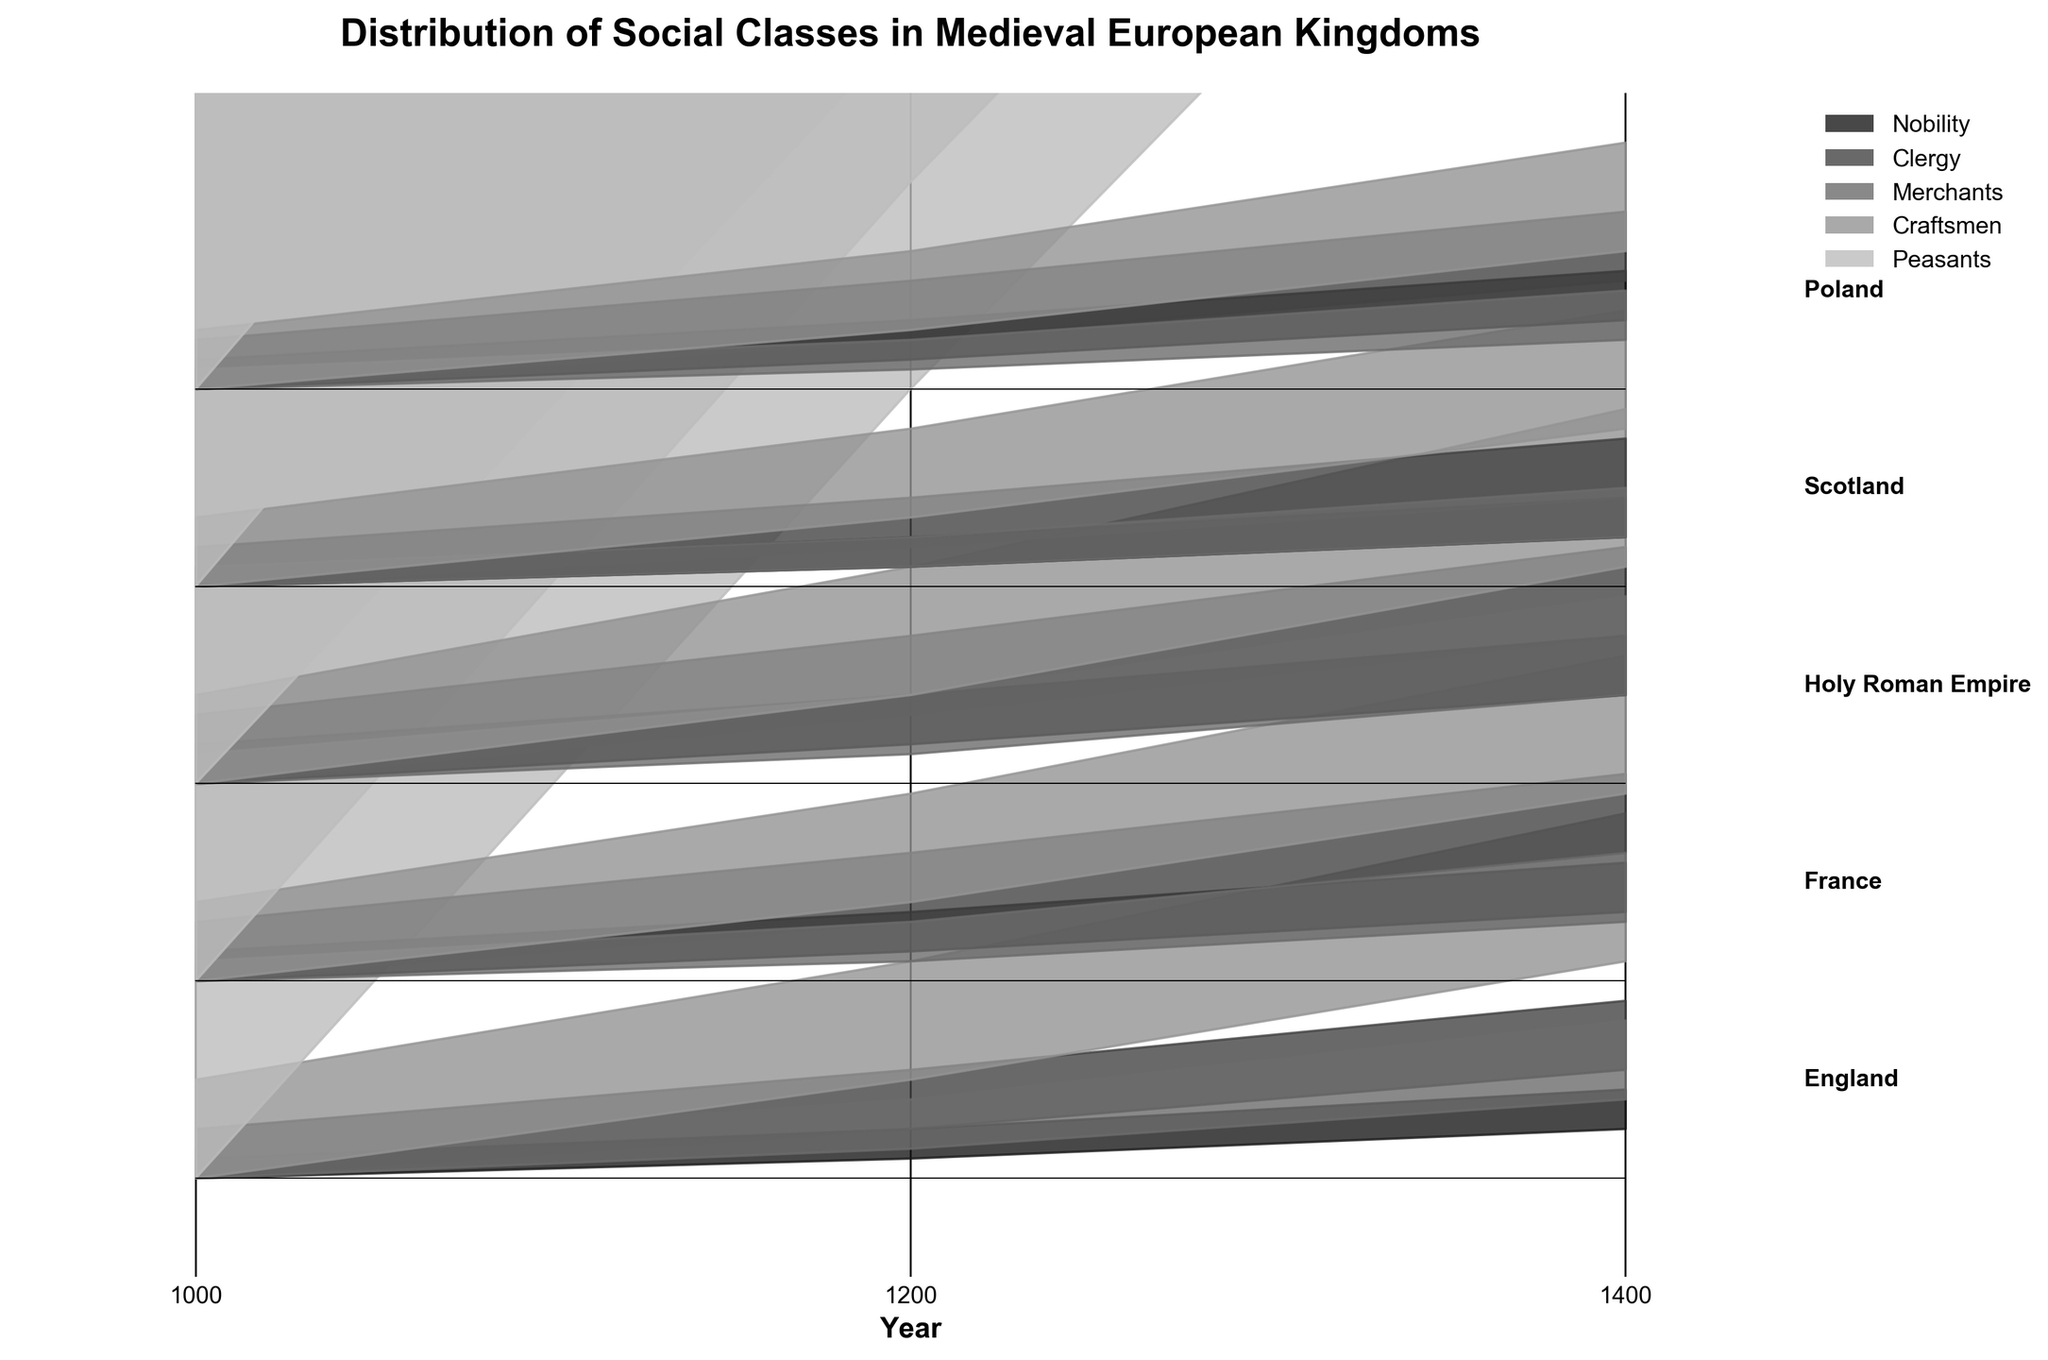What is the title of the figure? The title of the figure is displayed prominently at the top of the plot. It reads 'Distribution of Social Classes in Medieval European Kingdoms'.
Answer: Distribution of Social Classes in Medieval European Kingdoms Which two social classes have the highest and lowest cumulative values for England in the year 1200? By examining the figure, for England in the year 1200, the Peasants clearly have the highest cumulative value (bottommost white section), while the Nobility have the lowest (topmost dark section).
Answer: Peasants (highest), Nobility (lowest) Which kingdom shows the largest increase in the Merchant class from 1000 to 1400? In the plot, the Holy Roman Empire shows a noticeable increase in the size of the Merchant class segment from 1000 (small section) to 1400 (larger section).
Answer: Holy Roman Empire Compare the proportions of the Clergy class between France and Poland in the year 1200. For the year 1200, we can see that, in France, the Clergy class is larger (a moderately thick second section from the top) compared to Poland, where the Clergy section is slightly smaller.
Answer: France > Poland What is the general trend for the Craftsmen class in all kingdoms over time? Observing the Craftsmen class segments across all kingdoms from 1000 to 1400, we notice a common trend of increasing size, indicating a growth in this social class over time.
Answer: Increasing By how much did the Nobility class in Scotland grow from 1000 to 1400? Looking at the Nobility class (first section) in Scotland, in 1000, it’s a small segment, and by 1400, it has grown noticeably. To quantify: in 1000, it was 2 units high and in 1400, it is 4 units high. Therefore, it increased by 2 units.
Answer: 2 units Which kingdom has the most balanced distribution of social classes in the year 1400? For 1400, observing the plots, France shows the most balanced distribution of social classes, with each segment appearing relatively proportional to each other.
Answer: France How does the trend in the Peasants class from 1000 to 1400 in Poland compare with that in England? The Peasants class segment in both Poland and England shows a decreasing trend from 1000 to 1400. However, it appears that England’s decrease is sharper compared to Poland’s steadier decline.
Answer: England (sharper decline), Poland (steadier decline) Between 1200 and 1400, which kingdom shows the smallest change in the Merchants class? By examining the Merchants segments between 1200 and 1400 for all kingdoms, Scotland’s Merchants class shows the smallest visible change, suggesting a small increase compared to other kingdoms.
Answer: Scotland 